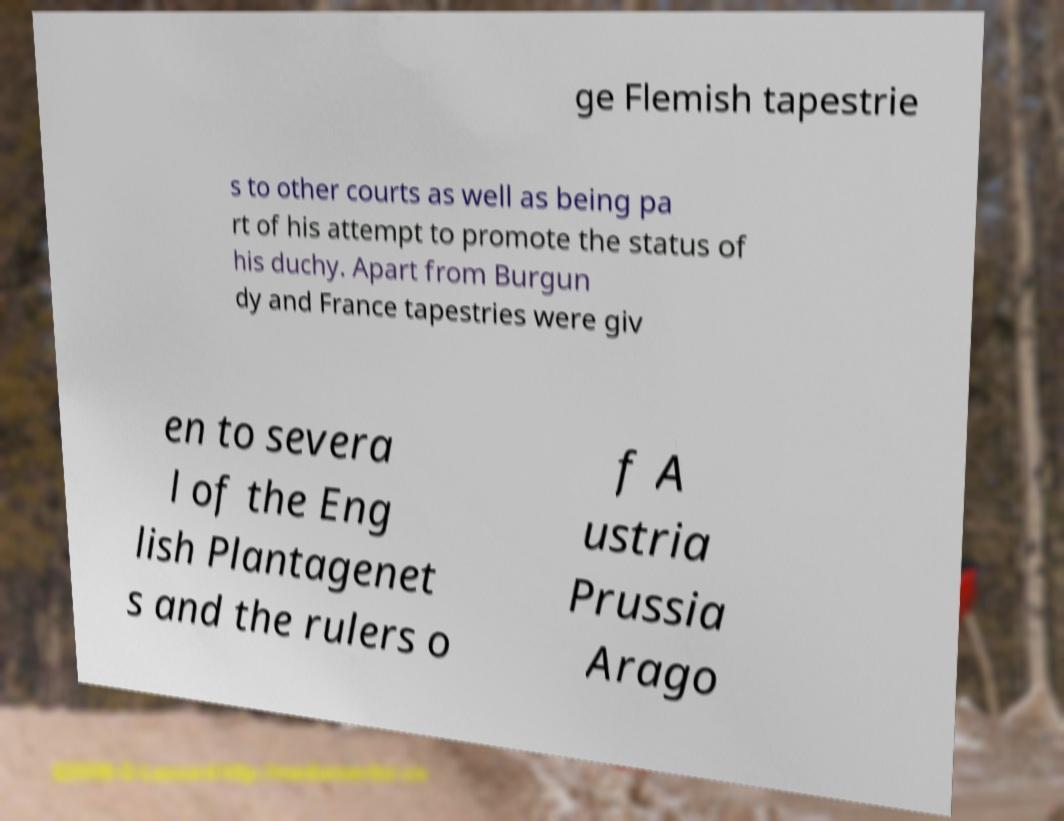For documentation purposes, I need the text within this image transcribed. Could you provide that? ge Flemish tapestrie s to other courts as well as being pa rt of his attempt to promote the status of his duchy. Apart from Burgun dy and France tapestries were giv en to severa l of the Eng lish Plantagenet s and the rulers o f A ustria Prussia Arago 